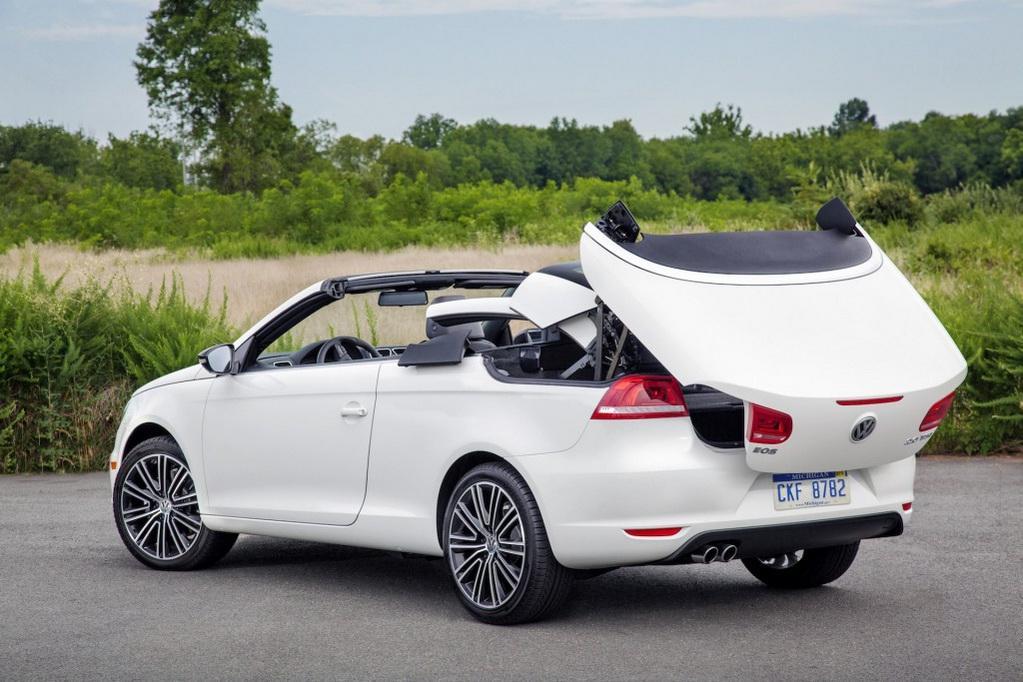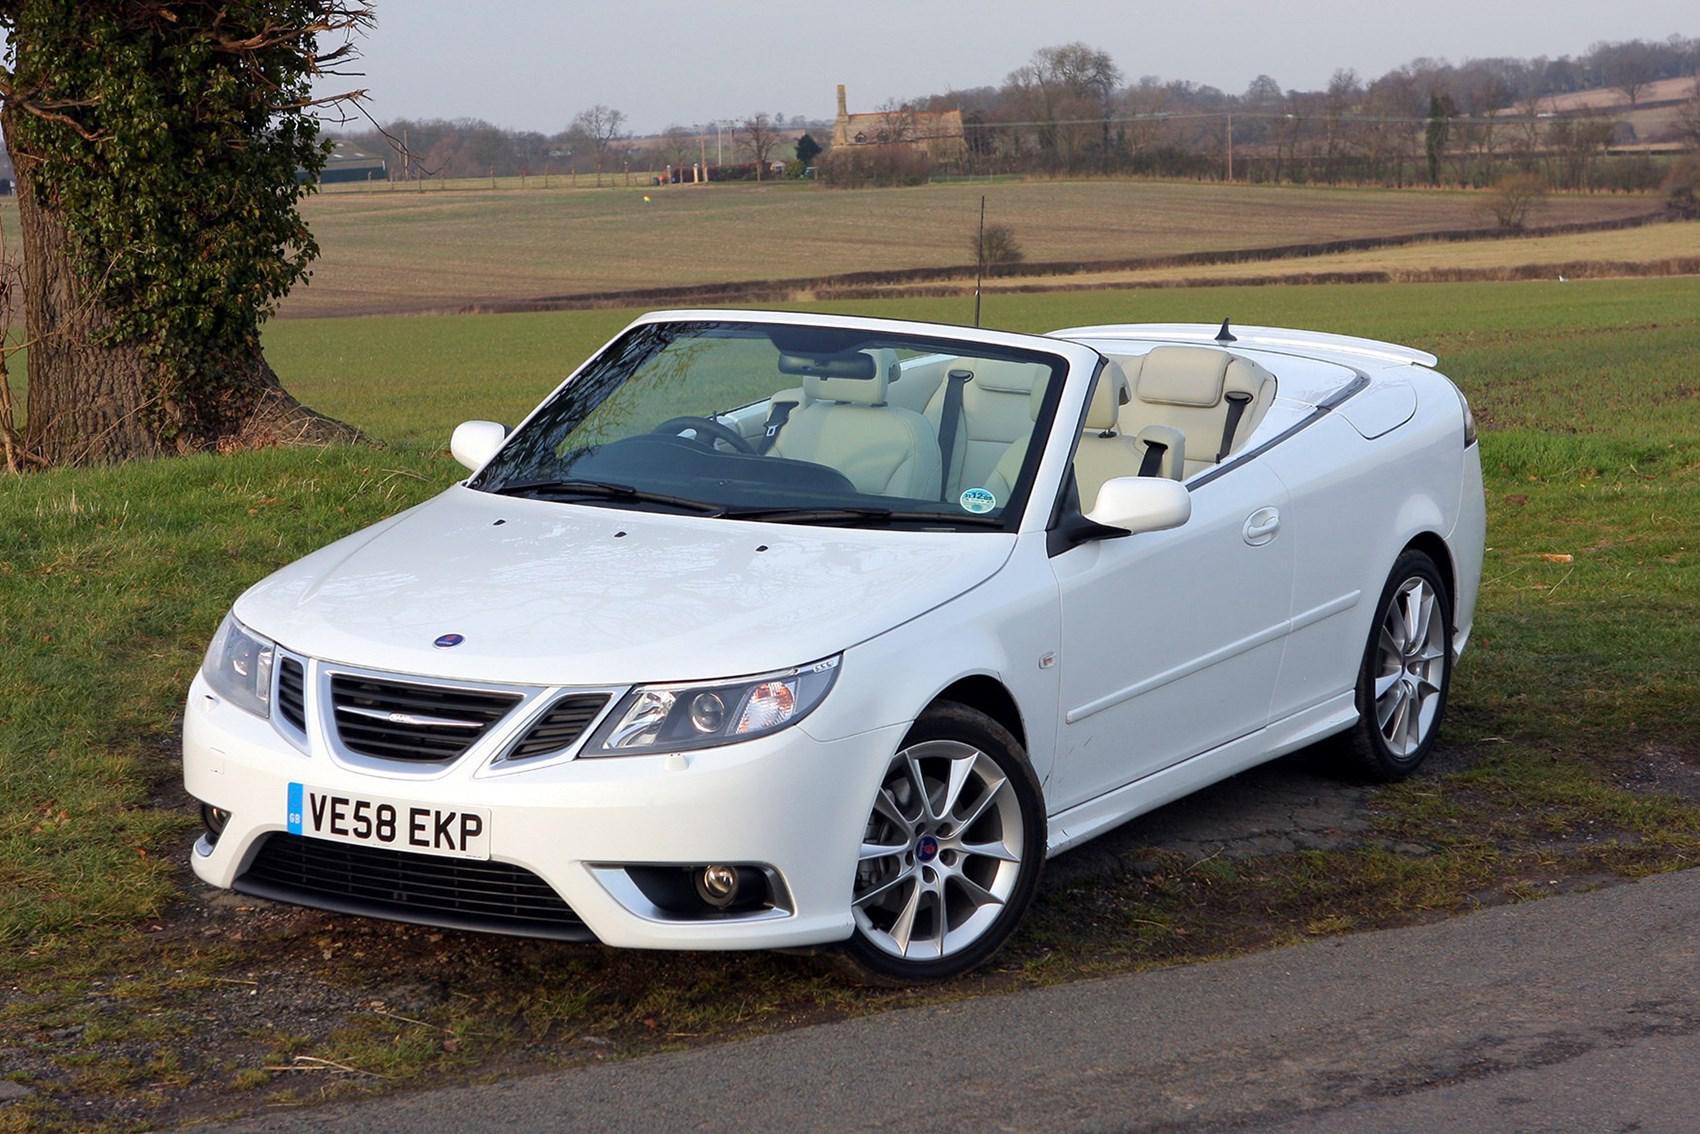The first image is the image on the left, the second image is the image on the right. Evaluate the accuracy of this statement regarding the images: "The image on the left features a white convertible.". Is it true? Answer yes or no. Yes. The first image is the image on the left, the second image is the image on the right. For the images shown, is this caption "All the cars are white." true? Answer yes or no. Yes. 